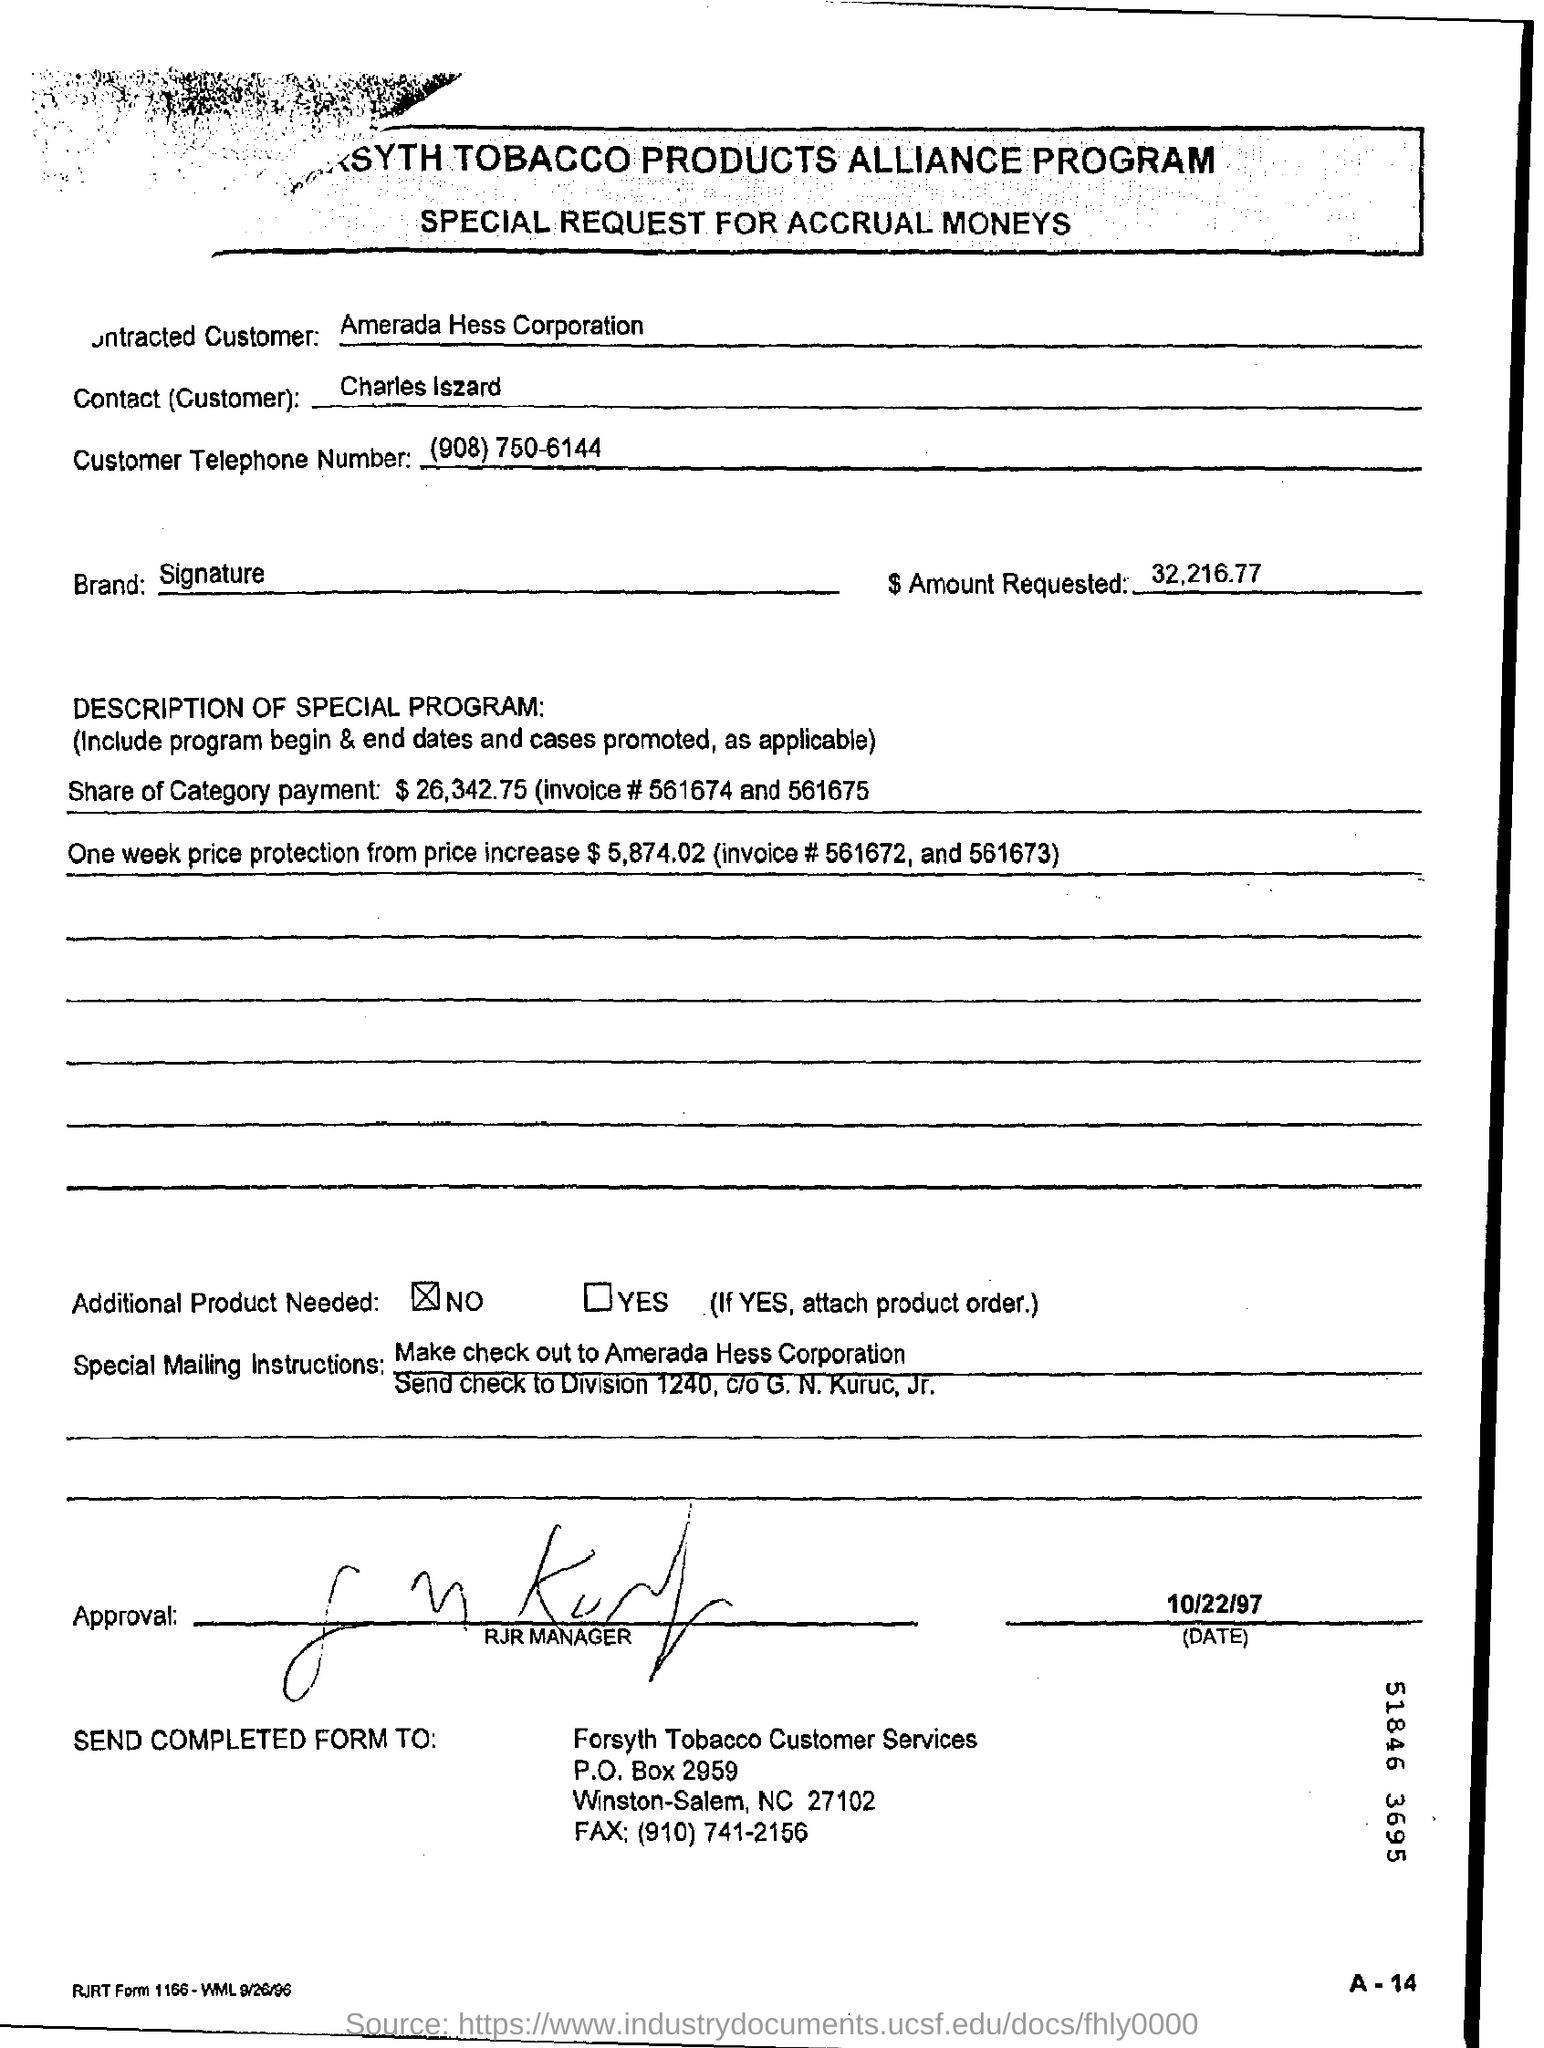Who is the contracted customer ?
Your answer should be very brief. Amerada Hess corporation. Who is the contact(customer) mentioned in the form?
Your answer should be very brief. Charles Iszard. How much amount is requested ?
Your answer should be compact. 32,216.77. What is the customer telephone number ?
Your response must be concise. (908) 750-6144. Is the additional product needed checked?
Offer a very short reply. No. What is the p.o. box number of forsyth tobacco customer services?
Your response must be concise. 2959. What is the name of contact(customer)?
Keep it short and to the point. Charles Iszard. How much is the share of category payment ?
Give a very brief answer. $ 26,342.75. 